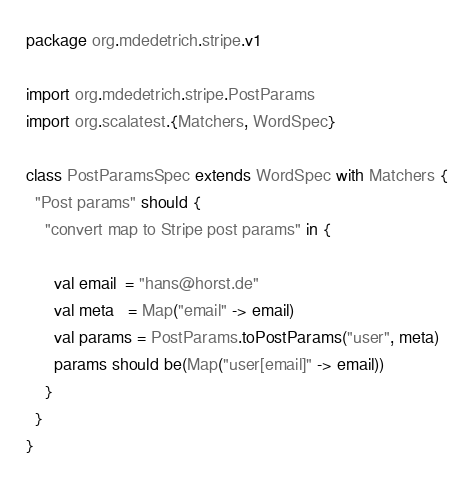<code> <loc_0><loc_0><loc_500><loc_500><_Scala_>package org.mdedetrich.stripe.v1

import org.mdedetrich.stripe.PostParams
import org.scalatest.{Matchers, WordSpec}

class PostParamsSpec extends WordSpec with Matchers {
  "Post params" should {
    "convert map to Stripe post params" in {

      val email  = "hans@horst.de"
      val meta   = Map("email" -> email)
      val params = PostParams.toPostParams("user", meta)
      params should be(Map("user[email]" -> email))
    }
  }
}
</code> 